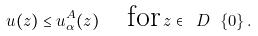Convert formula to latex. <formula><loc_0><loc_0><loc_500><loc_500>u ( z ) \leq u _ { \alpha } ^ { A } ( z ) \quad \text {for} \, z \in \ D \ \{ 0 \} \, .</formula> 